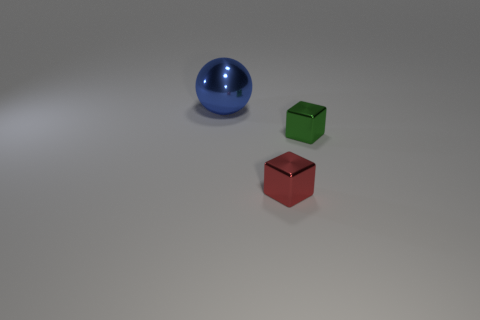Add 3 large blue shiny things. How many objects exist? 6 Subtract all cubes. How many objects are left? 1 Subtract all shiny balls. Subtract all small red cubes. How many objects are left? 1 Add 1 blue metal spheres. How many blue metal spheres are left? 2 Add 1 blue spheres. How many blue spheres exist? 2 Subtract 0 brown balls. How many objects are left? 3 